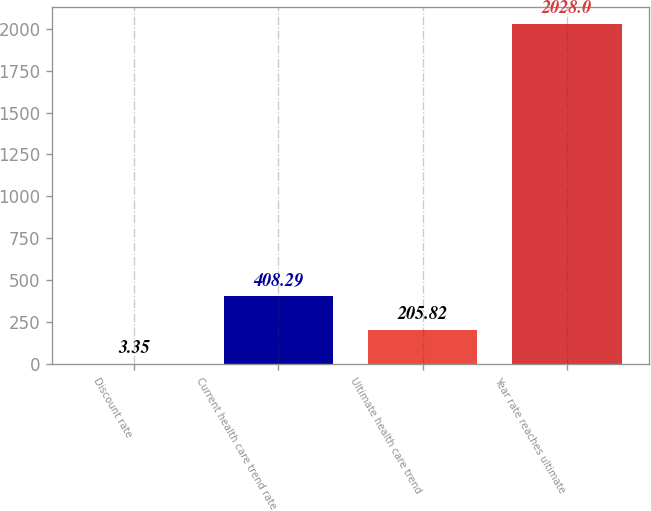Convert chart to OTSL. <chart><loc_0><loc_0><loc_500><loc_500><bar_chart><fcel>Discount rate<fcel>Current health care trend rate<fcel>Ultimate health care trend<fcel>Year rate reaches ultimate<nl><fcel>3.35<fcel>408.29<fcel>205.82<fcel>2028<nl></chart> 